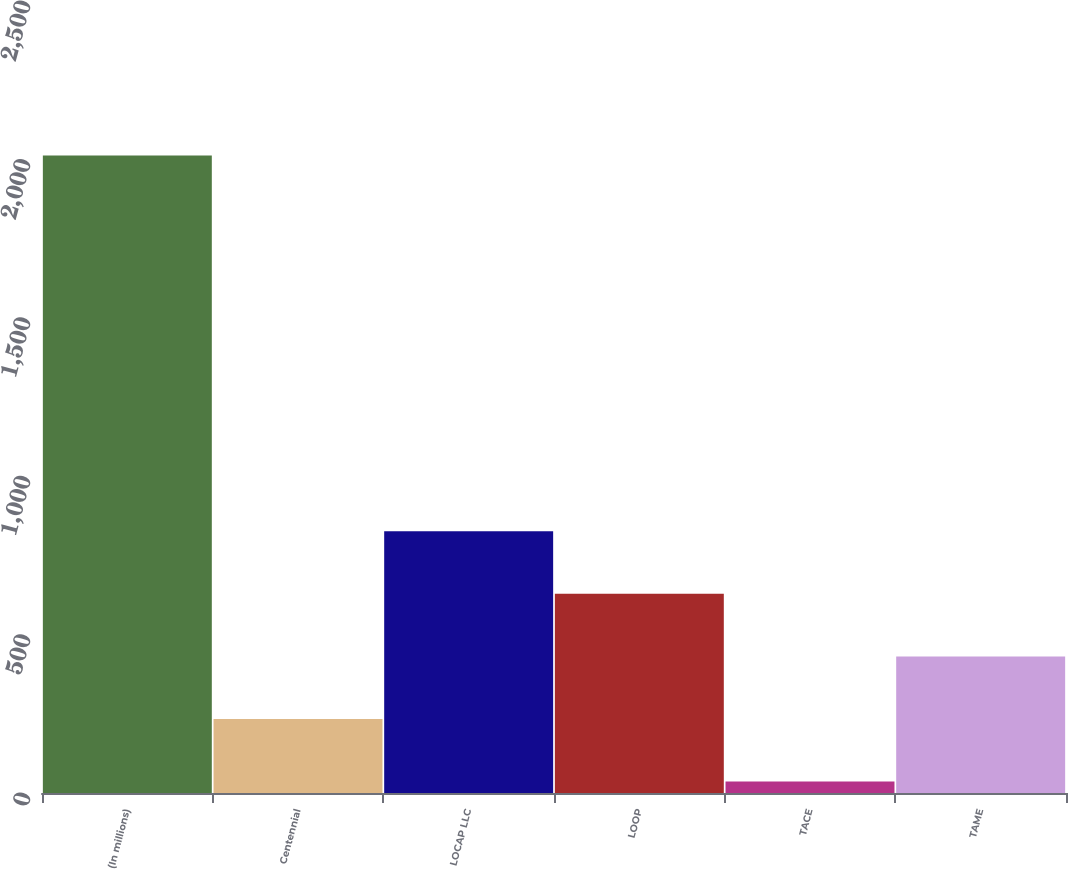<chart> <loc_0><loc_0><loc_500><loc_500><bar_chart><fcel>(In millions)<fcel>Centennial<fcel>LOCAP LLC<fcel>LOOP<fcel>TACE<fcel>TAME<nl><fcel>2012<fcel>233.6<fcel>826.4<fcel>628.8<fcel>36<fcel>431.2<nl></chart> 